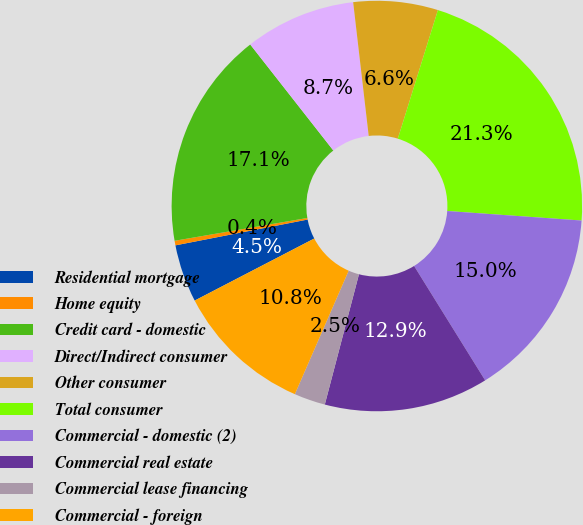<chart> <loc_0><loc_0><loc_500><loc_500><pie_chart><fcel>Residential mortgage<fcel>Home equity<fcel>Credit card - domestic<fcel>Direct/Indirect consumer<fcel>Other consumer<fcel>Total consumer<fcel>Commercial - domestic (2)<fcel>Commercial real estate<fcel>Commercial lease financing<fcel>Commercial - foreign<nl><fcel>4.55%<fcel>0.36%<fcel>17.13%<fcel>8.74%<fcel>6.65%<fcel>21.32%<fcel>15.03%<fcel>12.93%<fcel>2.46%<fcel>10.84%<nl></chart> 